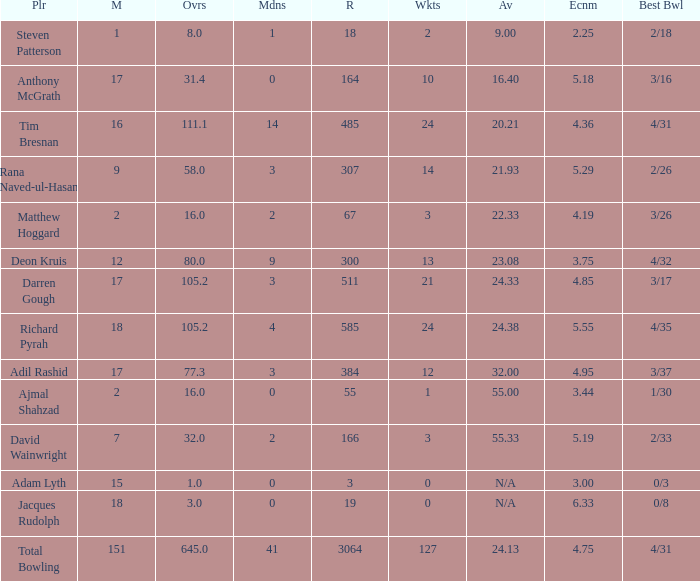What is the lowest Overs with a Run that is 18? 8.0. 